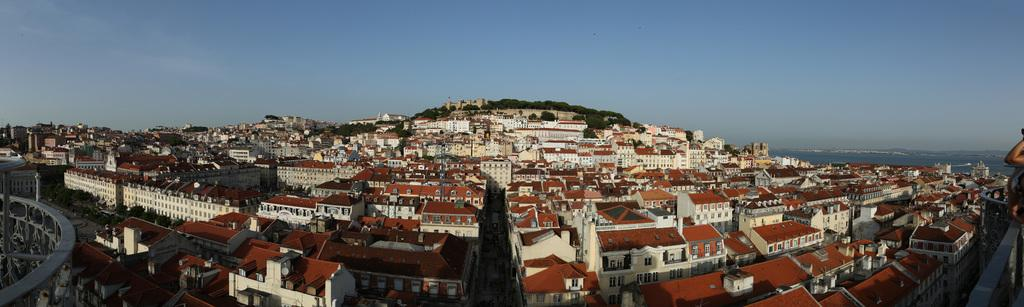What type of structures can be seen in the image? There are buildings in the image. What can be seen in the background of the image? There are trees, clouds, and the sky visible in the background of the image. What might be the purpose of the hands of people on the right side of the image? The hands of people on the right side of the image might be interacting with the buildings or trees, but it is not clear from the image alone. What type of flower is being used as a calculator in the image? There is no flower or calculator present in the image. How many sheep can be seen grazing in the background of the image? There are no sheep present in the image; only trees, clouds, and the sky are visible in the background. 